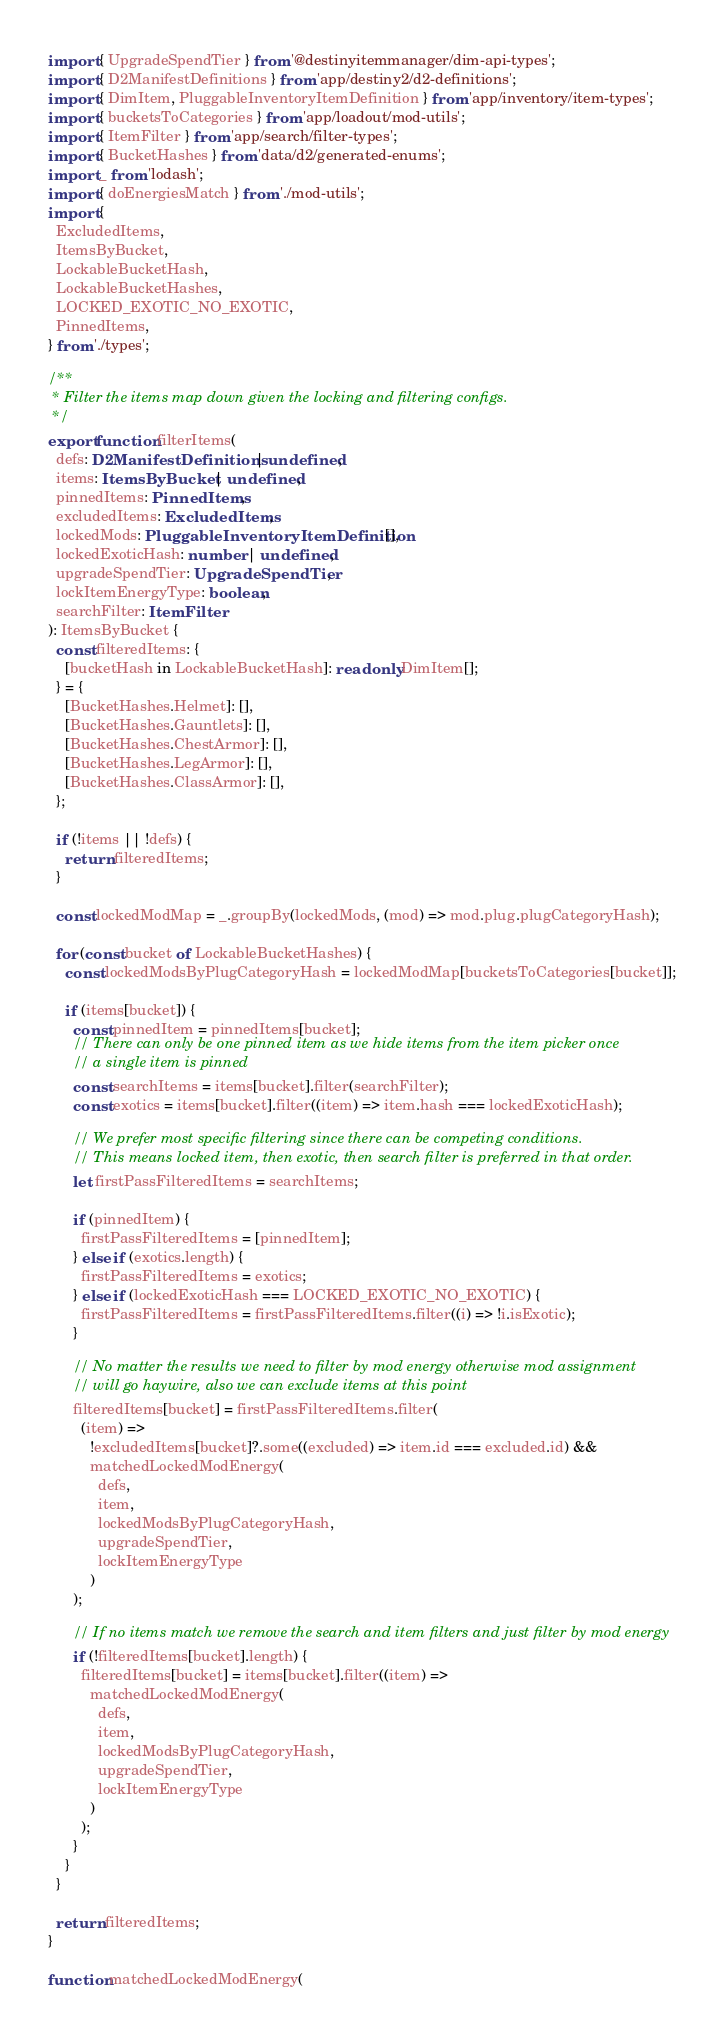<code> <loc_0><loc_0><loc_500><loc_500><_TypeScript_>import { UpgradeSpendTier } from '@destinyitemmanager/dim-api-types';
import { D2ManifestDefinitions } from 'app/destiny2/d2-definitions';
import { DimItem, PluggableInventoryItemDefinition } from 'app/inventory/item-types';
import { bucketsToCategories } from 'app/loadout/mod-utils';
import { ItemFilter } from 'app/search/filter-types';
import { BucketHashes } from 'data/d2/generated-enums';
import _ from 'lodash';
import { doEnergiesMatch } from './mod-utils';
import {
  ExcludedItems,
  ItemsByBucket,
  LockableBucketHash,
  LockableBucketHashes,
  LOCKED_EXOTIC_NO_EXOTIC,
  PinnedItems,
} from './types';

/**
 * Filter the items map down given the locking and filtering configs.
 */
export function filterItems(
  defs: D2ManifestDefinitions | undefined,
  items: ItemsByBucket | undefined,
  pinnedItems: PinnedItems,
  excludedItems: ExcludedItems,
  lockedMods: PluggableInventoryItemDefinition[],
  lockedExoticHash: number | undefined,
  upgradeSpendTier: UpgradeSpendTier,
  lockItemEnergyType: boolean,
  searchFilter: ItemFilter
): ItemsByBucket {
  const filteredItems: {
    [bucketHash in LockableBucketHash]: readonly DimItem[];
  } = {
    [BucketHashes.Helmet]: [],
    [BucketHashes.Gauntlets]: [],
    [BucketHashes.ChestArmor]: [],
    [BucketHashes.LegArmor]: [],
    [BucketHashes.ClassArmor]: [],
  };

  if (!items || !defs) {
    return filteredItems;
  }

  const lockedModMap = _.groupBy(lockedMods, (mod) => mod.plug.plugCategoryHash);

  for (const bucket of LockableBucketHashes) {
    const lockedModsByPlugCategoryHash = lockedModMap[bucketsToCategories[bucket]];

    if (items[bucket]) {
      const pinnedItem = pinnedItems[bucket];
      // There can only be one pinned item as we hide items from the item picker once
      // a single item is pinned
      const searchItems = items[bucket].filter(searchFilter);
      const exotics = items[bucket].filter((item) => item.hash === lockedExoticHash);

      // We prefer most specific filtering since there can be competing conditions.
      // This means locked item, then exotic, then search filter is preferred in that order.
      let firstPassFilteredItems = searchItems;

      if (pinnedItem) {
        firstPassFilteredItems = [pinnedItem];
      } else if (exotics.length) {
        firstPassFilteredItems = exotics;
      } else if (lockedExoticHash === LOCKED_EXOTIC_NO_EXOTIC) {
        firstPassFilteredItems = firstPassFilteredItems.filter((i) => !i.isExotic);
      }

      // No matter the results we need to filter by mod energy otherwise mod assignment
      // will go haywire, also we can exclude items at this point
      filteredItems[bucket] = firstPassFilteredItems.filter(
        (item) =>
          !excludedItems[bucket]?.some((excluded) => item.id === excluded.id) &&
          matchedLockedModEnergy(
            defs,
            item,
            lockedModsByPlugCategoryHash,
            upgradeSpendTier,
            lockItemEnergyType
          )
      );

      // If no items match we remove the search and item filters and just filter by mod energy
      if (!filteredItems[bucket].length) {
        filteredItems[bucket] = items[bucket].filter((item) =>
          matchedLockedModEnergy(
            defs,
            item,
            lockedModsByPlugCategoryHash,
            upgradeSpendTier,
            lockItemEnergyType
          )
        );
      }
    }
  }

  return filteredItems;
}

function matchedLockedModEnergy(</code> 